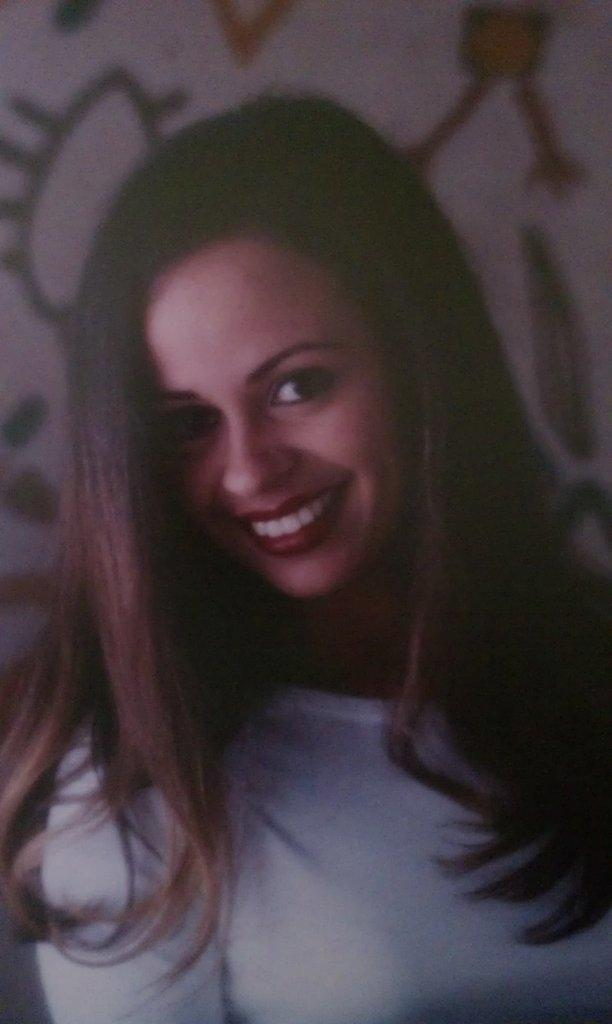Who is present in the image? There is a girl in the image. What is the girl's expression in the image? The girl is smiling in the image. What type of pies can be seen in the image? There are no pies present in the image; it only features a girl who is smiling. What time of day is it in the image? The provided facts do not mention the time of day, so it cannot be determined from the image. 